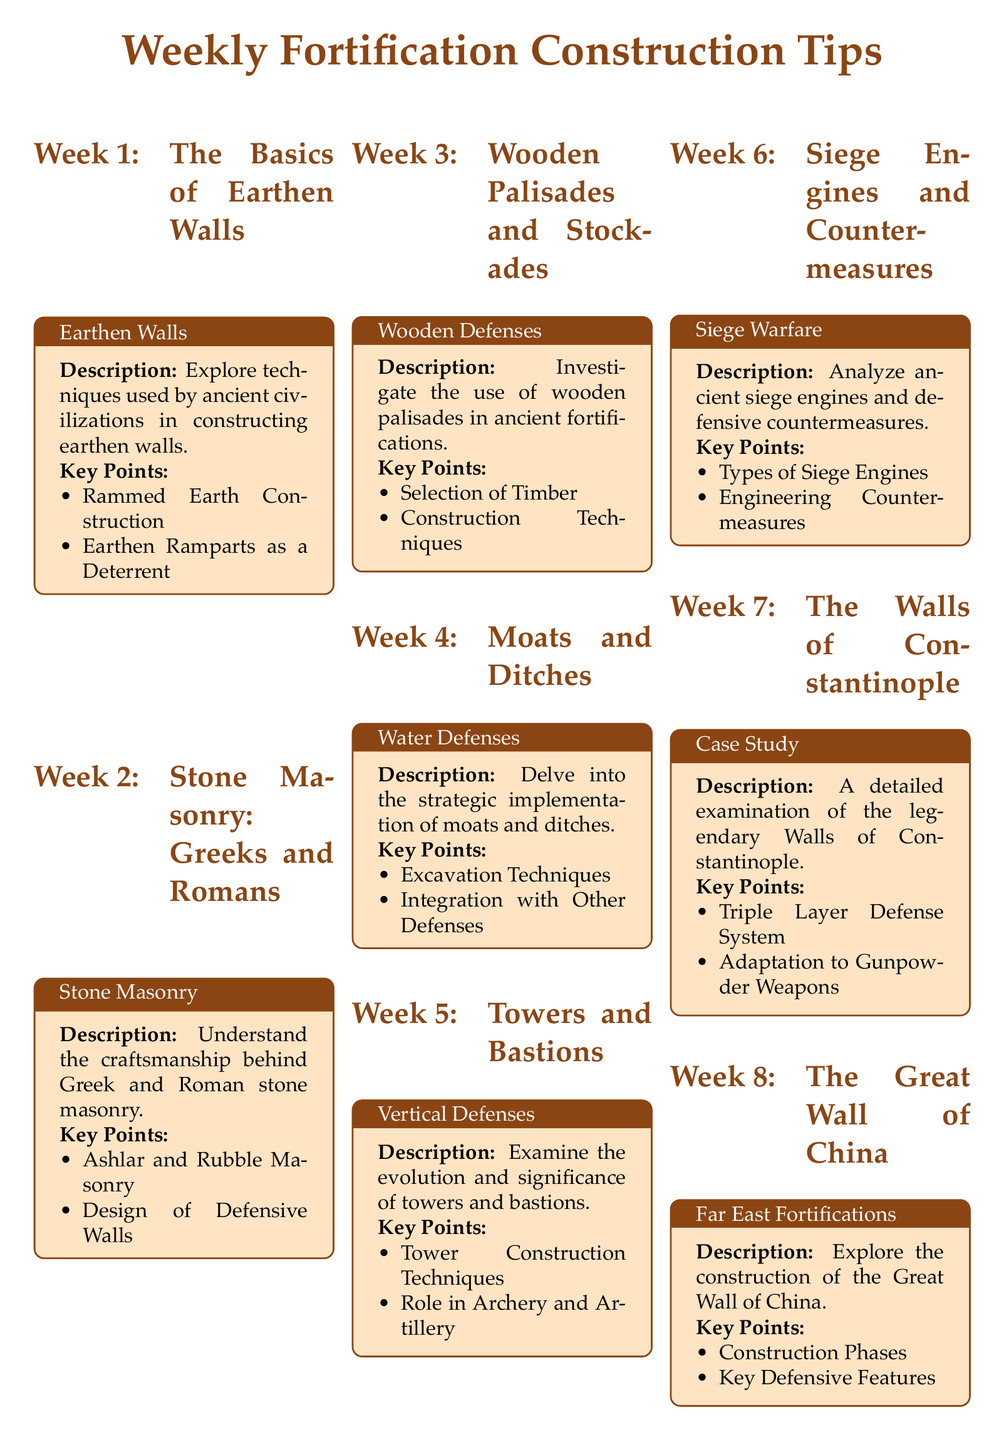What is the title of the document? The title of the document is presented at the beginning and indicates the theme of the content, which is focused on ancient fortification construction tips.
Answer: Weekly Fortification Construction Tips What week covers the topic of "The Great Wall of China"? Each week's topic is listed in the section headings, and the Great Wall of China is discussed in the eighth section of the document.
Answer: Week 8 What is a key defensive feature of the Great Wall of China mentioned in the document? Key features are highlighted in each week’s summary, with emphasis on what makes the construction significant or effective.
Answer: Key Defensive Features Which civilizations are specifically mentioned in relation to stone masonry? The document specifies the civilizations associated with the topic discussed in each section, focusing on Greek and Roman craftsmanship.
Answer: Greeks and Romans What type of defensive structure is analyzed in the week on "Siege Warfare"? The weekly topics cover different structures and methods, where siege engines are specifically analyzed in this week’s focus.
Answer: Siege Engines What is one of the excavation techniques linked to moats and ditches? Key points in each section provide insight into the methods used, illustrating practical techniques within the discussions.
Answer: Excavation Techniques In what week is the topic of "Siege Resilience" discussed? The week number correlates directly to the title of the topic that assesses food and water storage during sieges.
Answer: Week 11 Which ancient fortification's walls are detailed in a case study? The document indicates a detailed examination of a specific fortification as a case study, highlighting its unique construction and defense.
Answer: The Walls of Constantinople What is the focus of the week on "Wooden Defenses"? Each week’s focus is summarized, and the wooden defenses specifically relate to palisades and their construction methods.
Answer: Wooden Palisades 